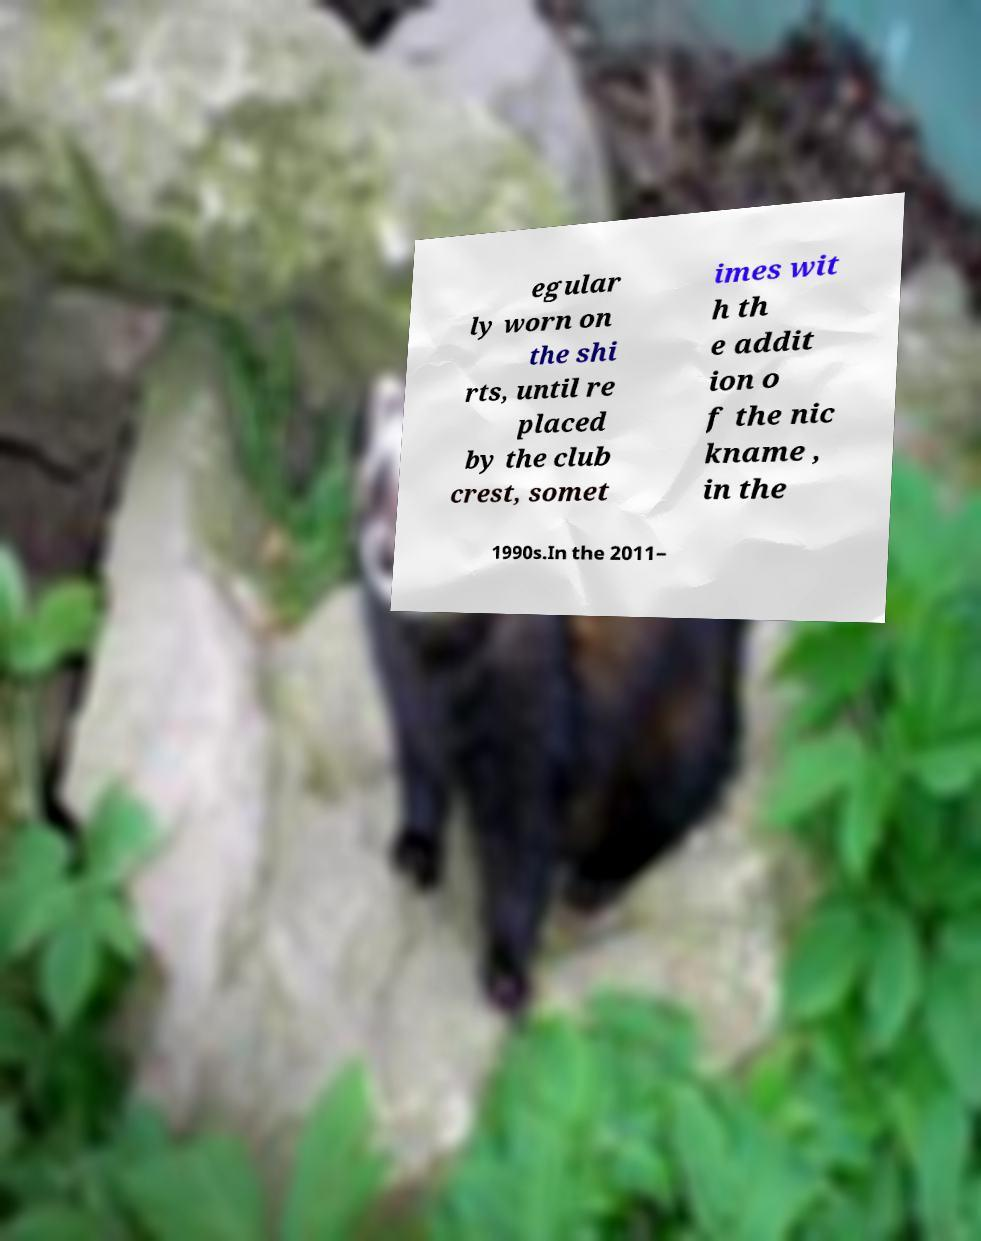Can you accurately transcribe the text from the provided image for me? egular ly worn on the shi rts, until re placed by the club crest, somet imes wit h th e addit ion o f the nic kname , in the 1990s.In the 2011– 